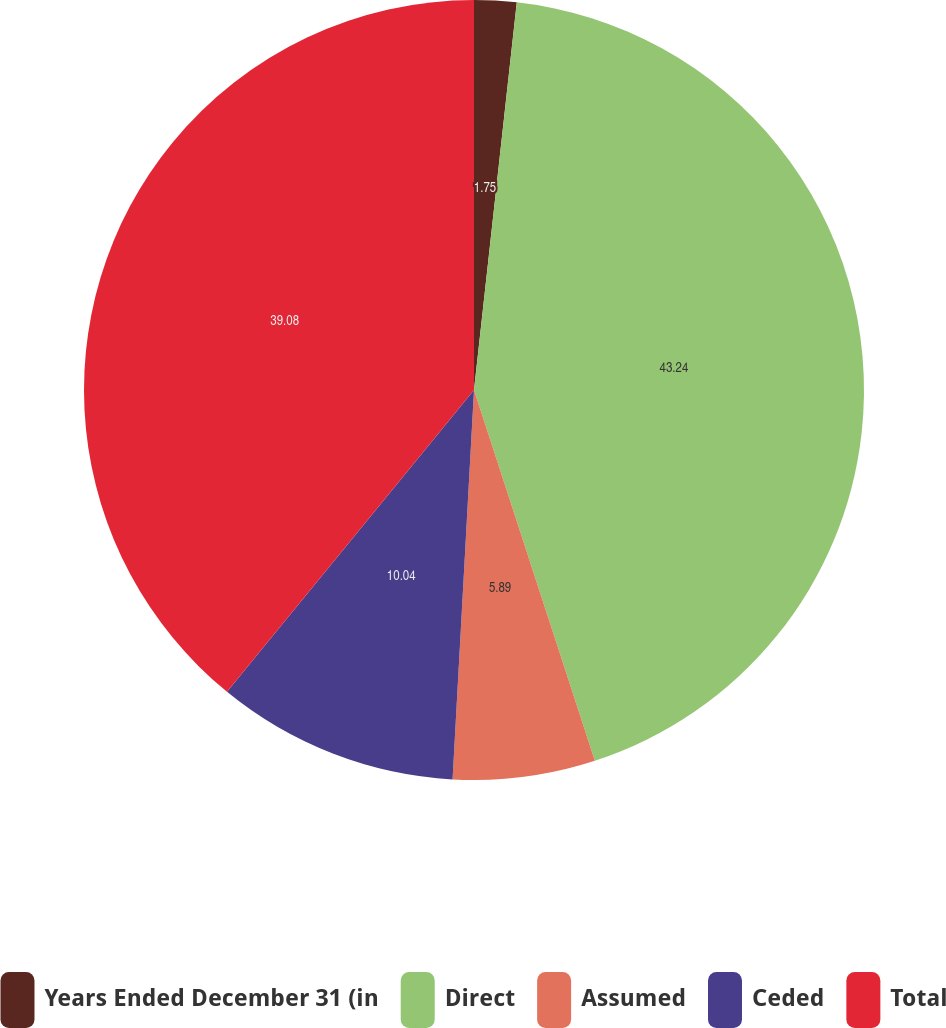<chart> <loc_0><loc_0><loc_500><loc_500><pie_chart><fcel>Years Ended December 31 (in<fcel>Direct<fcel>Assumed<fcel>Ceded<fcel>Total<nl><fcel>1.75%<fcel>43.23%<fcel>5.89%<fcel>10.04%<fcel>39.08%<nl></chart> 